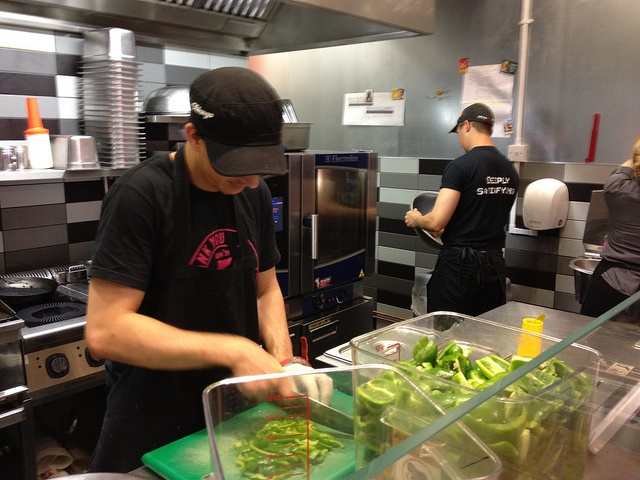Describe the objects in this image and their specific colors. I can see people in black, tan, and maroon tones, oven in black, maroon, and gray tones, people in black, tan, maroon, and gray tones, oven in black, maroon, gray, and darkgray tones, and people in black, gray, and maroon tones in this image. 